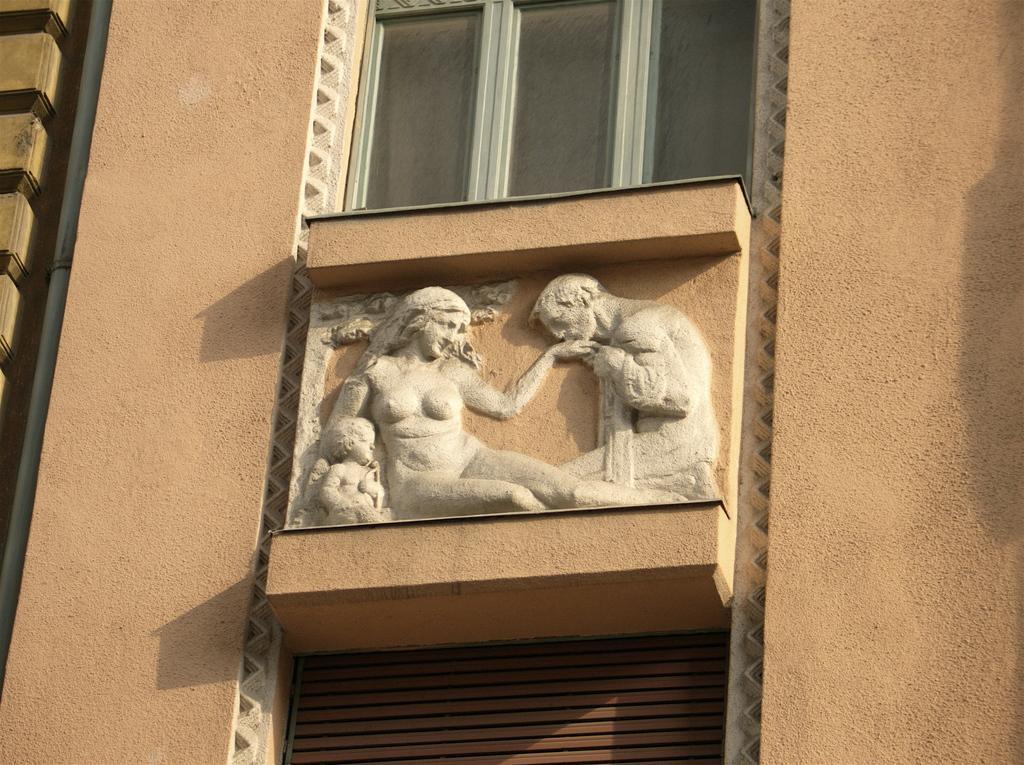Can you describe this image briefly? In this image we can see sculptures, wall, pipe on the wall on the left side, windows and objects. 